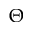<formula> <loc_0><loc_0><loc_500><loc_500>\Theta</formula> 